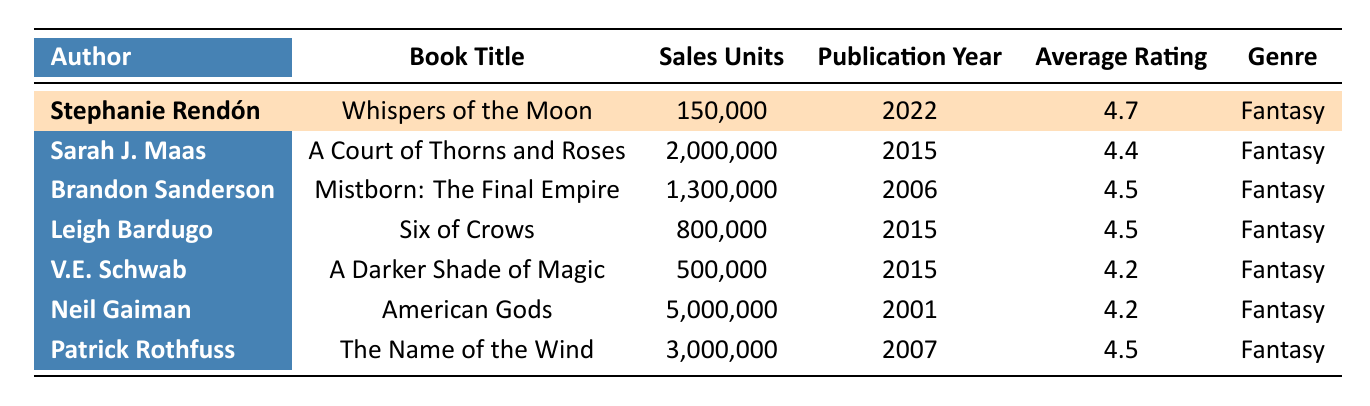What is the sales figure for Stephanie Rendón's book? According to the table, Stephanie Rendón's book "Whispers of the Moon" sold 150,000 units.
Answer: 150,000 Which book has the highest sales figure? From the table, Neil Gaiman's "American Gods" has the highest sales figure with 5,000,000 units sold.
Answer: American Gods What is the average rating of V.E. Schwab's book? The table shows that V.E. Schwab's book "A Darker Shade of Magic" has an average rating of 4.2.
Answer: 4.2 What is the total sales of all the books listed in the table? The total sales can be calculated by summing all the sales figures: 150,000 + 2,000,000 + 1,300,000 + 800,000 + 500,000 + 5,000,000 + 3,000,000 = 12,750,000 units.
Answer: 12,750,000 True or False: "Whispers of the Moon" was published before 2015. The publication year of "Whispers of the Moon" is 2022, which is after 2015, making the statement false.
Answer: False Which author's book has the lowest number of sales? The sales figure for V.E. Schwab's "A Darker Shade of Magic" is the smallest at 500,000 units.
Answer: A Darker Shade of Magic What is the difference in sales units between "Whispers of the Moon" and "Six of Crows"? The sales for "Whispers of the Moon" is 150,000, and for "Six of Crows" it is 800,000. The difference is 800,000 - 150,000 = 650,000 units.
Answer: 650,000 How many authors in this table have an average rating above 4.5? Analyzing the average ratings in the table, Stephanie Rendón (4.7) is the only author with a rating above 4.5, while others like Sarah J. Maas, Brandon Sanderson, Leigh Bardugo, and Patrick Rothfuss are exactly 4.5 or lower.
Answer: 1 What is the average sales figure of the books listed? First, calculate the total sales: 12,750,000, then divide by the number of books (7), giving 12,750,000 / 7 = 1,821,429. The average sales figure is approximately 1,821,429 units.
Answer: 1,821,429 Which book published in 2015 has the highest average rating? "A Court of Thorns and Roses" by Sarah J. Maas published in 2015 has an average rating of 4.4, while "Six of Crows" and "A Darker Shade of Magic," both also published in 2015, have a rating of 4.5. Therefore, "Six of Crows" has the highest rating.
Answer: Six of Crows 